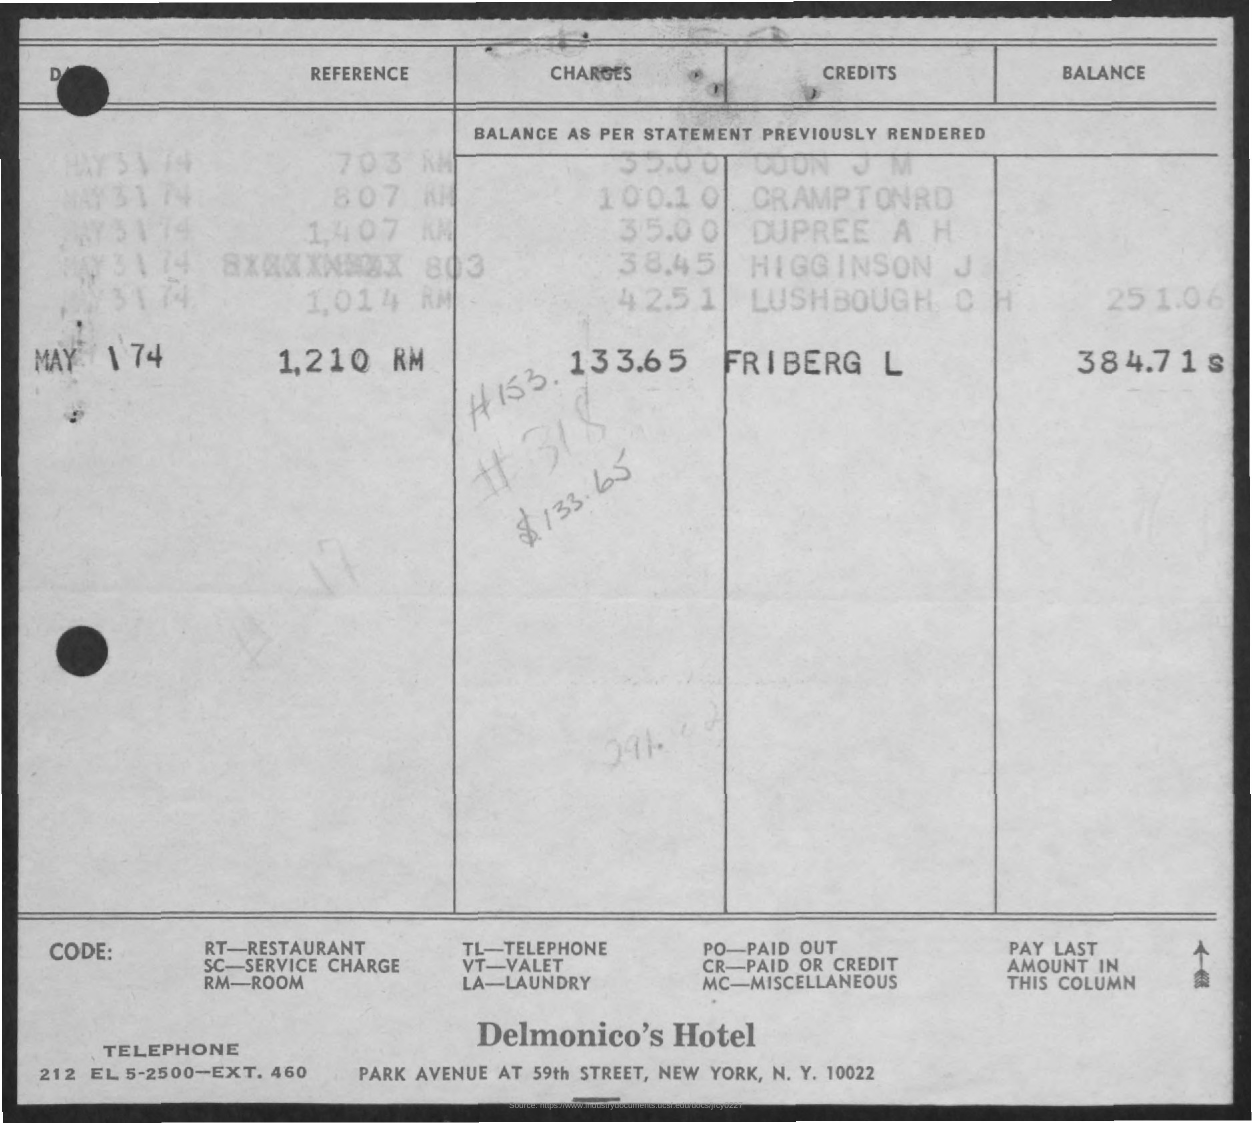Highlight a few significant elements in this photo. The full form of TL is "terminal loop", which is a part of a telephone system that connects the phone line to the telephone. Delmonico's Hotel is the name of the hotel. The full form of RM is Room Manager. The full form of RT is Restaurant. 